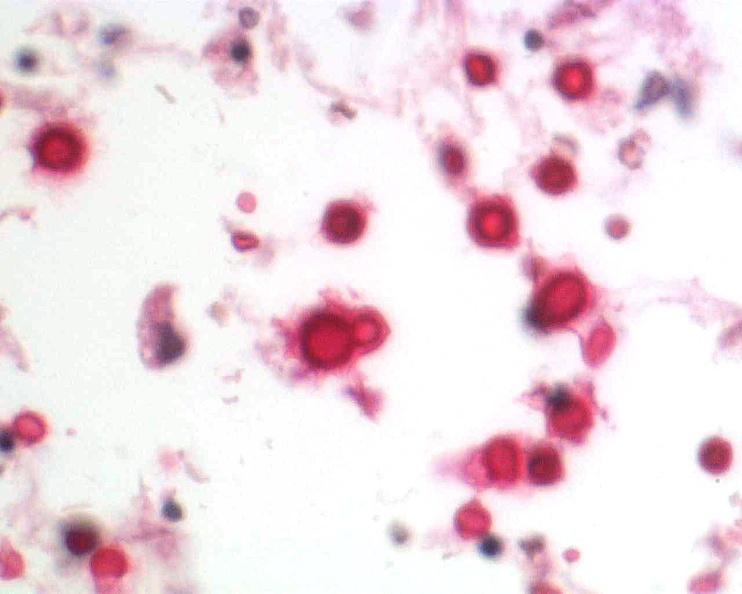what does this image show?
Answer the question using a single word or phrase. Brain 